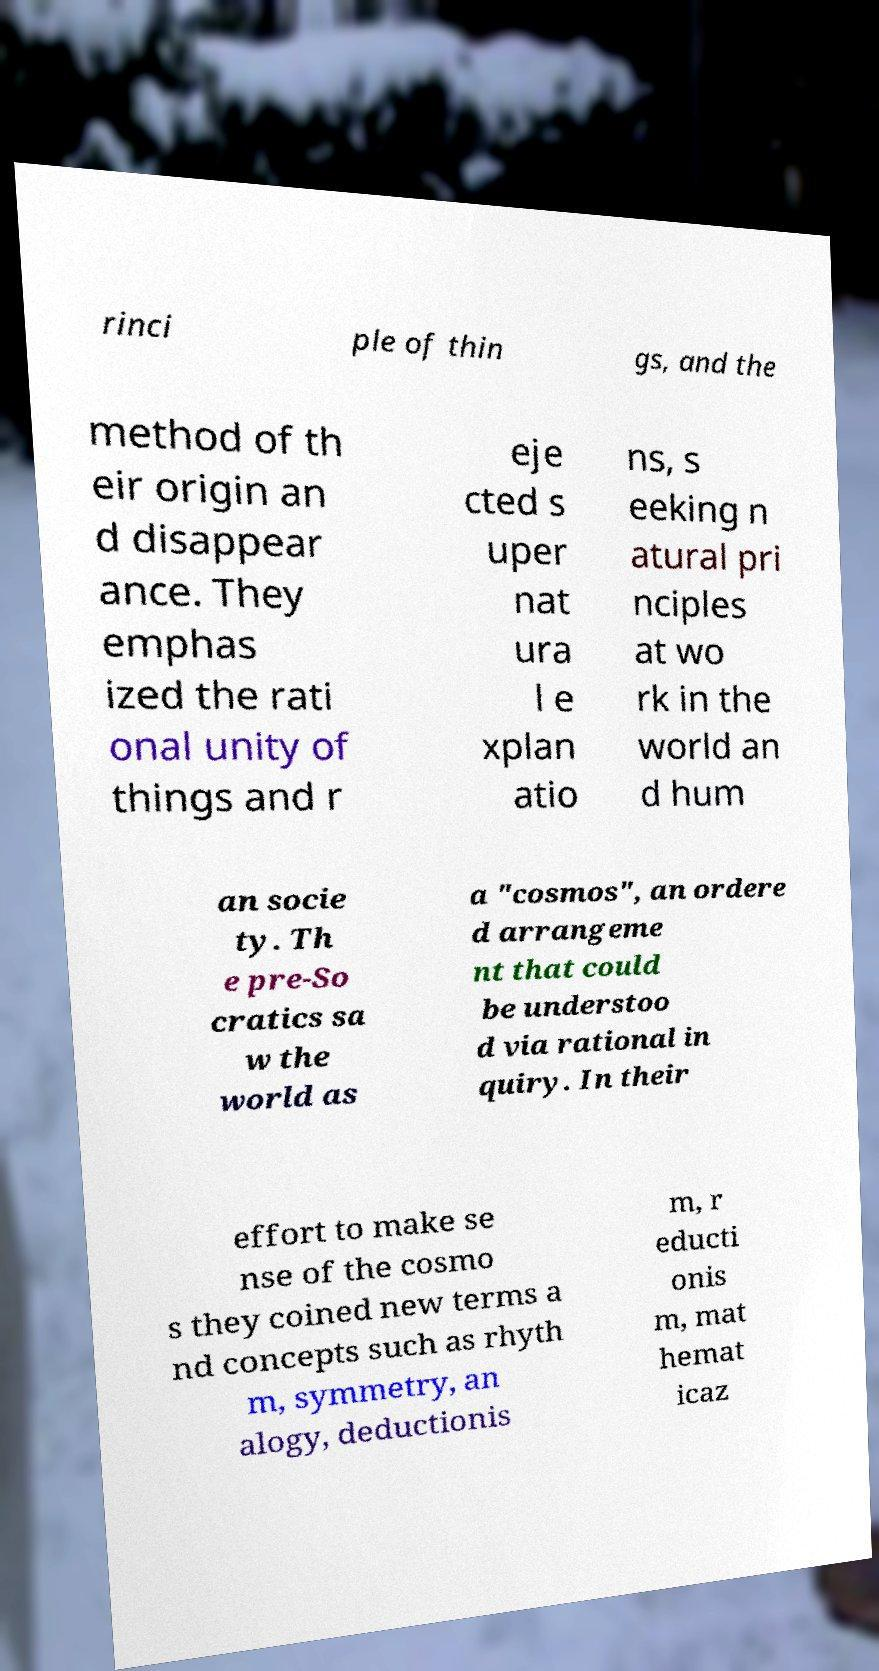Could you extract and type out the text from this image? rinci ple of thin gs, and the method of th eir origin an d disappear ance. They emphas ized the rati onal unity of things and r eje cted s uper nat ura l e xplan atio ns, s eeking n atural pri nciples at wo rk in the world an d hum an socie ty. Th e pre-So cratics sa w the world as a "cosmos", an ordere d arrangeme nt that could be understoo d via rational in quiry. In their effort to make se nse of the cosmo s they coined new terms a nd concepts such as rhyth m, symmetry, an alogy, deductionis m, r educti onis m, mat hemat icaz 